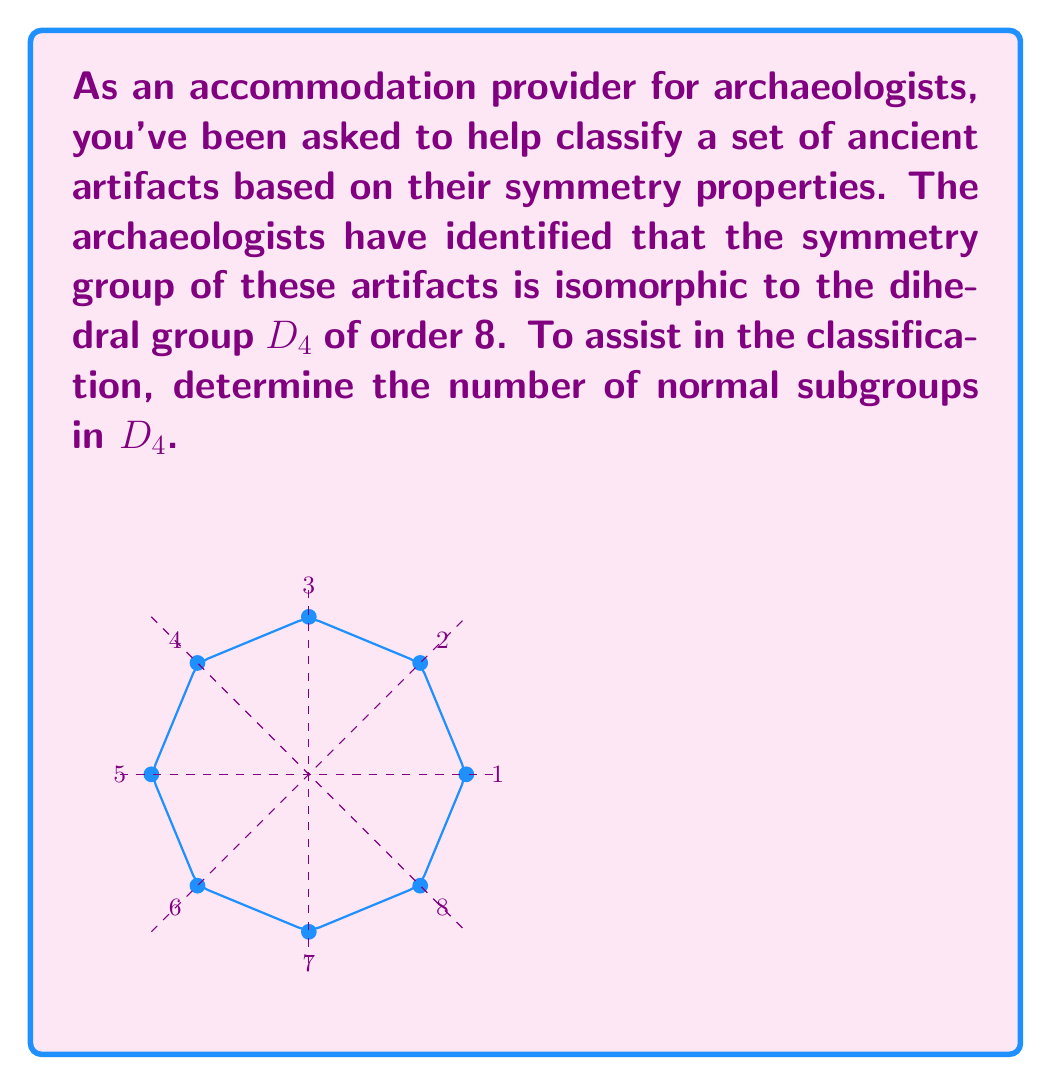Help me with this question. To find the number of normal subgroups in $D_4$, we'll follow these steps:

1) First, recall that $D_4$ is the symmetry group of a square, with 8 elements:
   - 4 rotations (including identity): $e, r, r^2, r^3$
   - 4 reflections: $s, sr, sr^2, sr^3$

2) The subgroups of $D_4$ are:
   - $\{e\}$ (trivial subgroup)
   - $\{e, r^2\}$ (order 2)
   - $\{e, s\}, \{e, sr\}, \{e, sr^2\}, \{e, sr^3\}$ (order 2)
   - $\{e, r, r^2, r^3\}$ (cyclic subgroup of order 4)
   - $D_4$ itself

3) To determine which of these are normal, we need to check if they are invariant under conjugation by all elements of $D_4$. A subgroup $H$ is normal if $gHg^{-1} = H$ for all $g \in D_4$.

4) The trivial subgroup $\{e\}$ and $D_4$ itself are always normal in any group.

5) $\{e, r^2\}$ is normal because $r^2$ commutes with all elements of $D_4$.

6) The cyclic subgroup $\{e, r, r^2, r^3\}$ is normal because it's of index 2 in $D_4$.

7) For the reflection subgroups of order 2:
   - $s(e)s^{-1} = e$ and $s(sr)s^{-1} = sr^3 \neq sr$
   - Similar conjugations show that none of these subgroups are normal.

Therefore, there are 4 normal subgroups in $D_4$:
$\{e\}, \{e, r^2\}, \{e, r, r^2, r^3\},$ and $D_4$ itself.
Answer: 4 